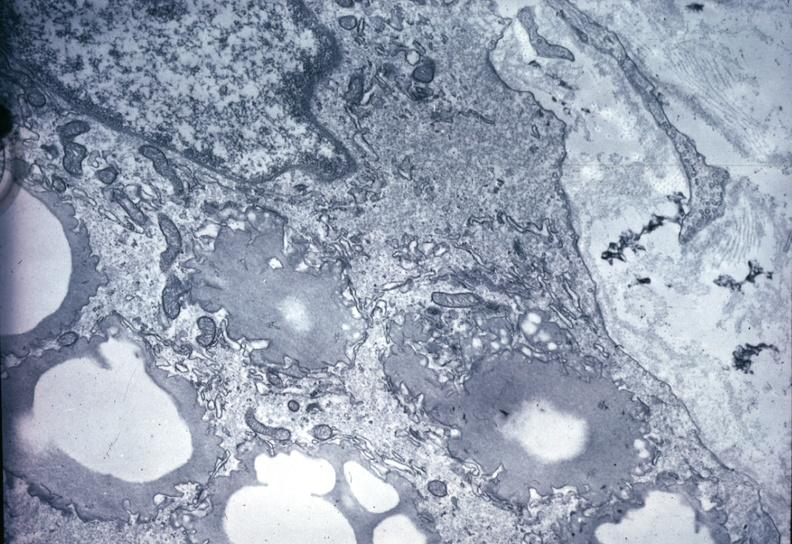do acute lymphocytic leukemia precipitate in interstitial space very good example outside case?
Answer the question using a single word or phrase. No 